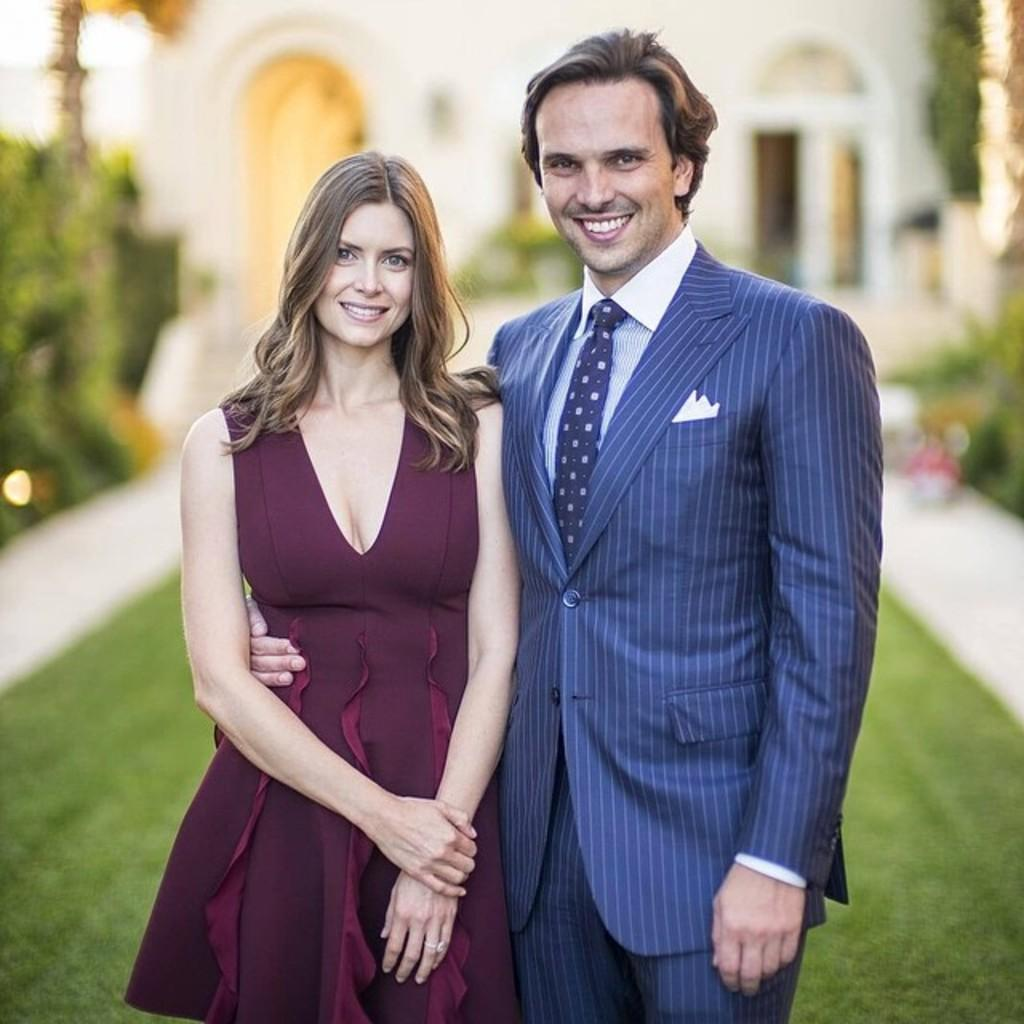What is the main subject of the image? The main subject of the image is a couple standing in the foreground. Can you describe the background of the image? The background of the image features greenery. What type of bells can be heard ringing in the image? There are no bells present in the image, and therefore no sound can be heard. 